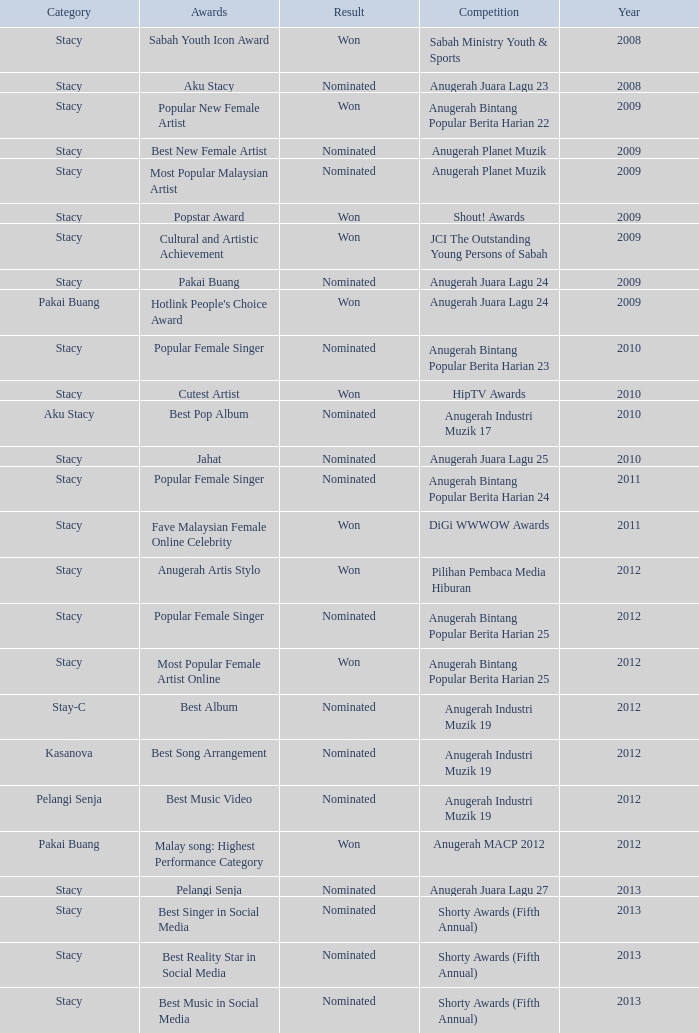What award was in the year after 2009 with a competition of Digi Wwwow Awards? Fave Malaysian Female Online Celebrity. 